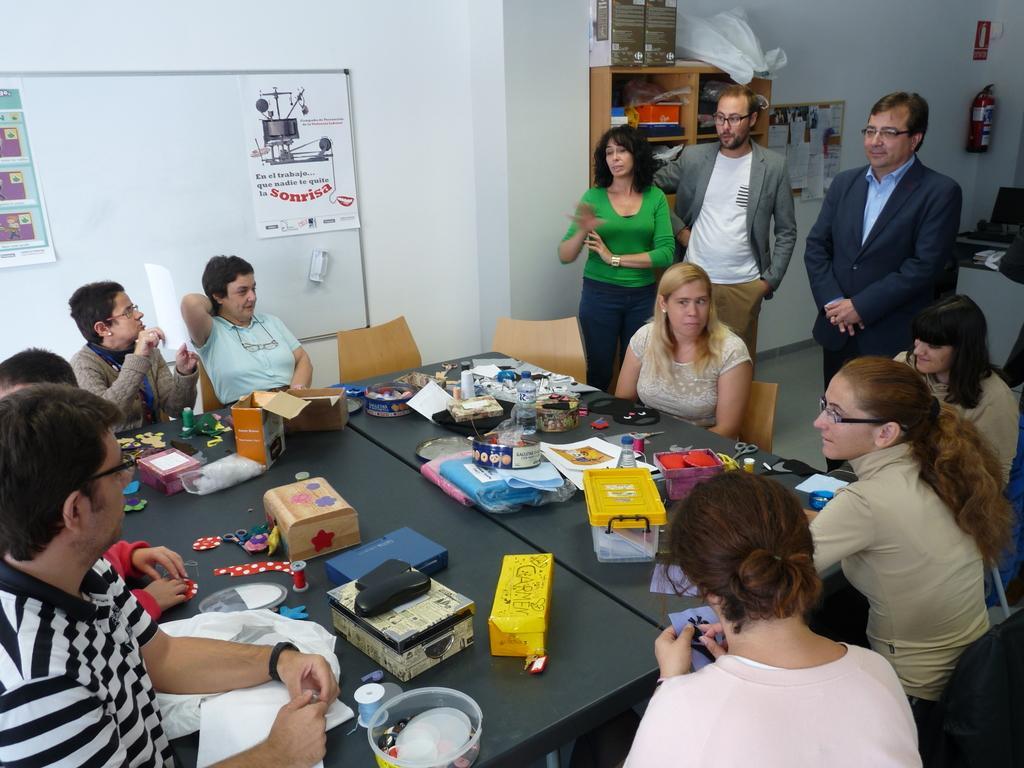How would you summarize this image in a sentence or two? In this image I can see number of people sitting on chairs around the black colored table and on the table I can see few boxes, few clothes, few scissors, a bottle, few papers and few other objects. In the background I can see the white colored wall, a white colored board, few posts attached to the board, few other persons standing, a cabinet, few objects in the cabinet and on the cabinet and a fire extinguisher. 